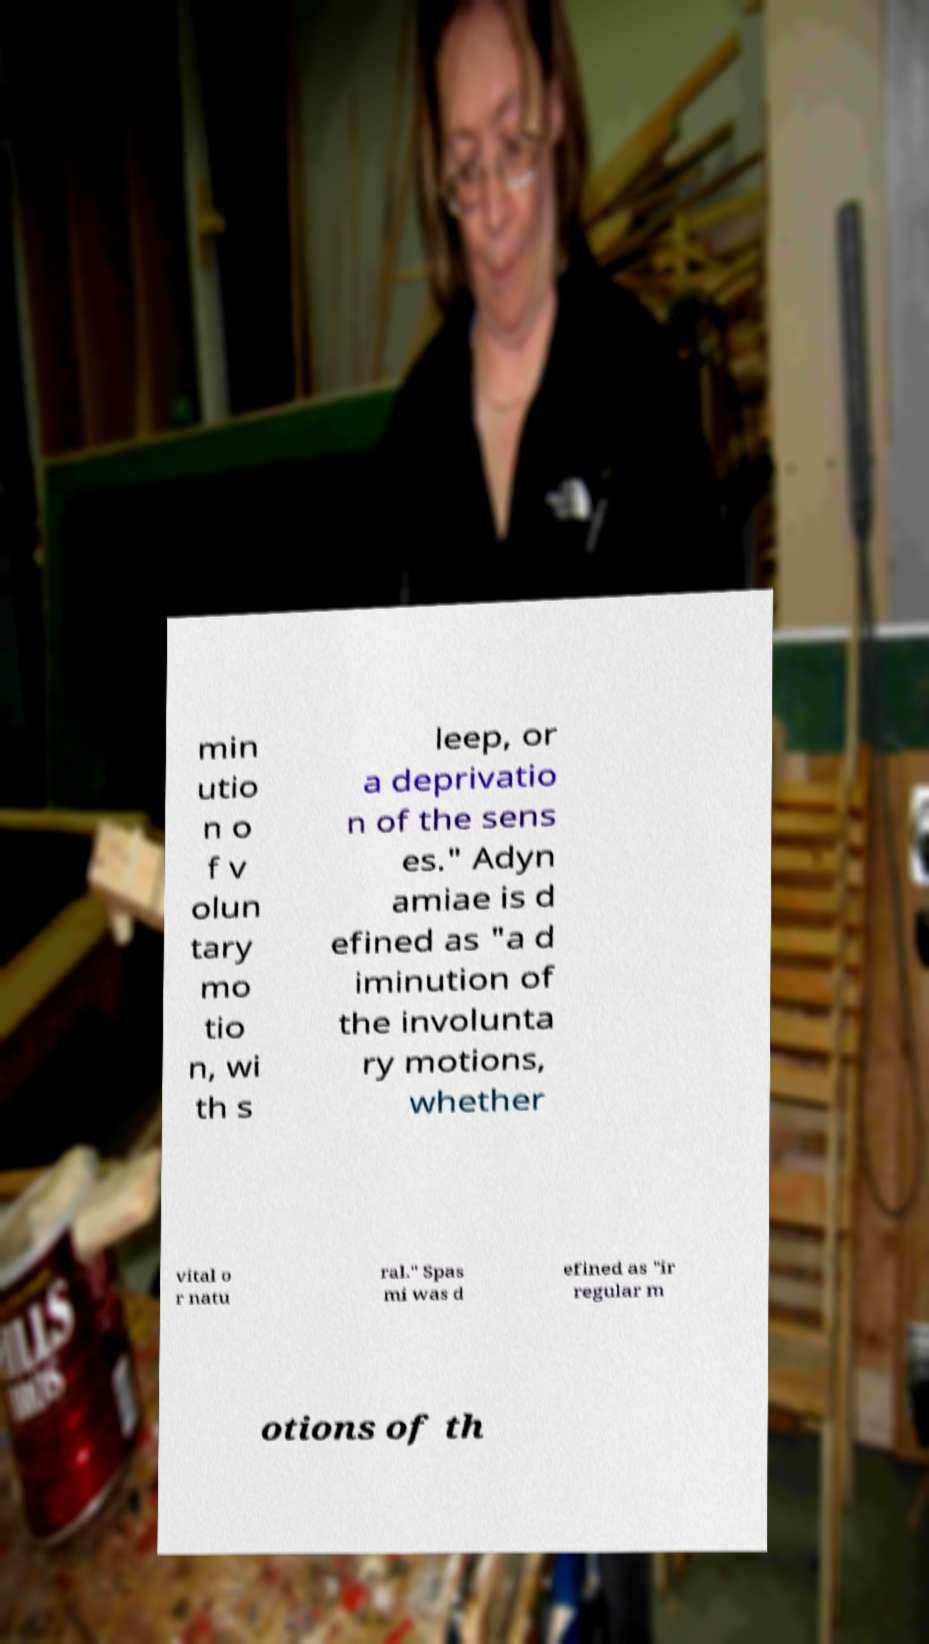There's text embedded in this image that I need extracted. Can you transcribe it verbatim? min utio n o f v olun tary mo tio n, wi th s leep, or a deprivatio n of the sens es." Adyn amiae is d efined as "a d iminution of the involunta ry motions, whether vital o r natu ral." Spas mi was d efined as "ir regular m otions of th 